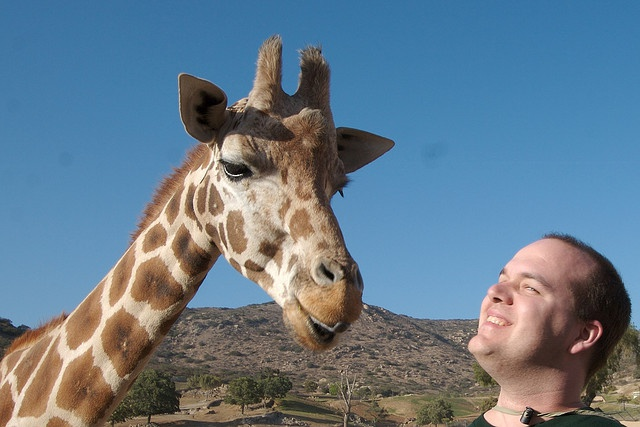Describe the objects in this image and their specific colors. I can see giraffe in gray, black, tan, and maroon tones and people in gray, black, lightpink, and maroon tones in this image. 